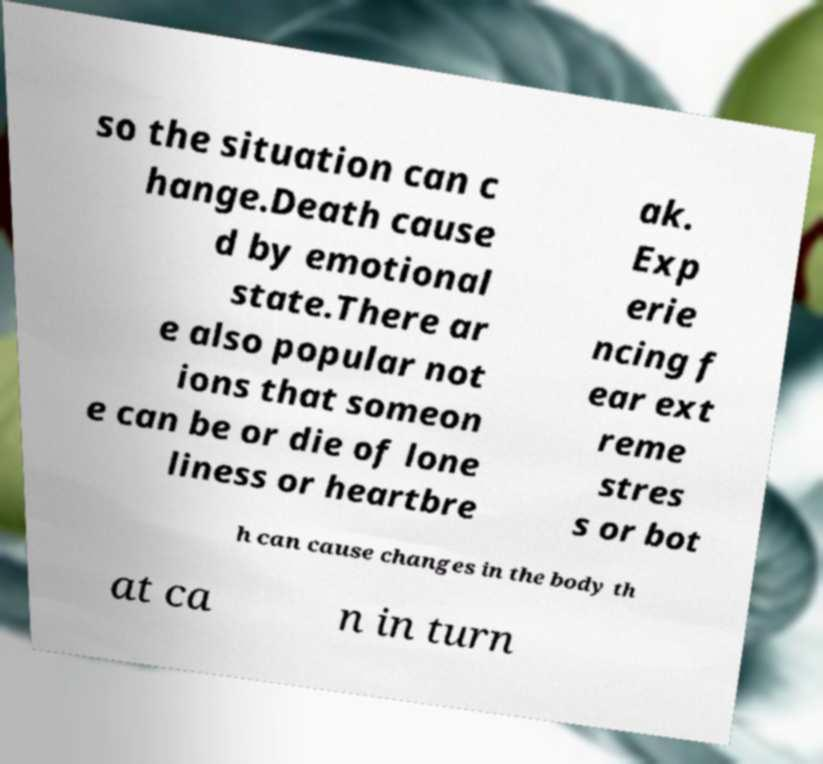For documentation purposes, I need the text within this image transcribed. Could you provide that? so the situation can c hange.Death cause d by emotional state.There ar e also popular not ions that someon e can be or die of lone liness or heartbre ak. Exp erie ncing f ear ext reme stres s or bot h can cause changes in the body th at ca n in turn 